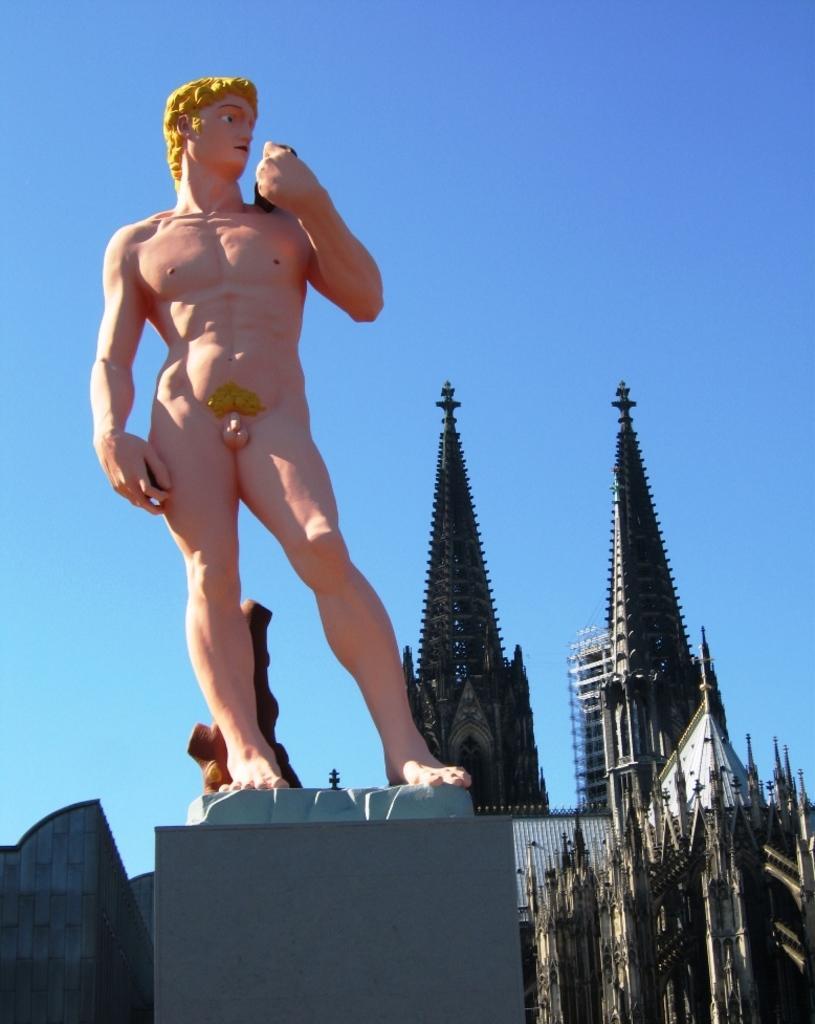Please provide a concise description of this image. There is a nude statue of a person on a platform. In the background, there are buildings and there is blue sky. 